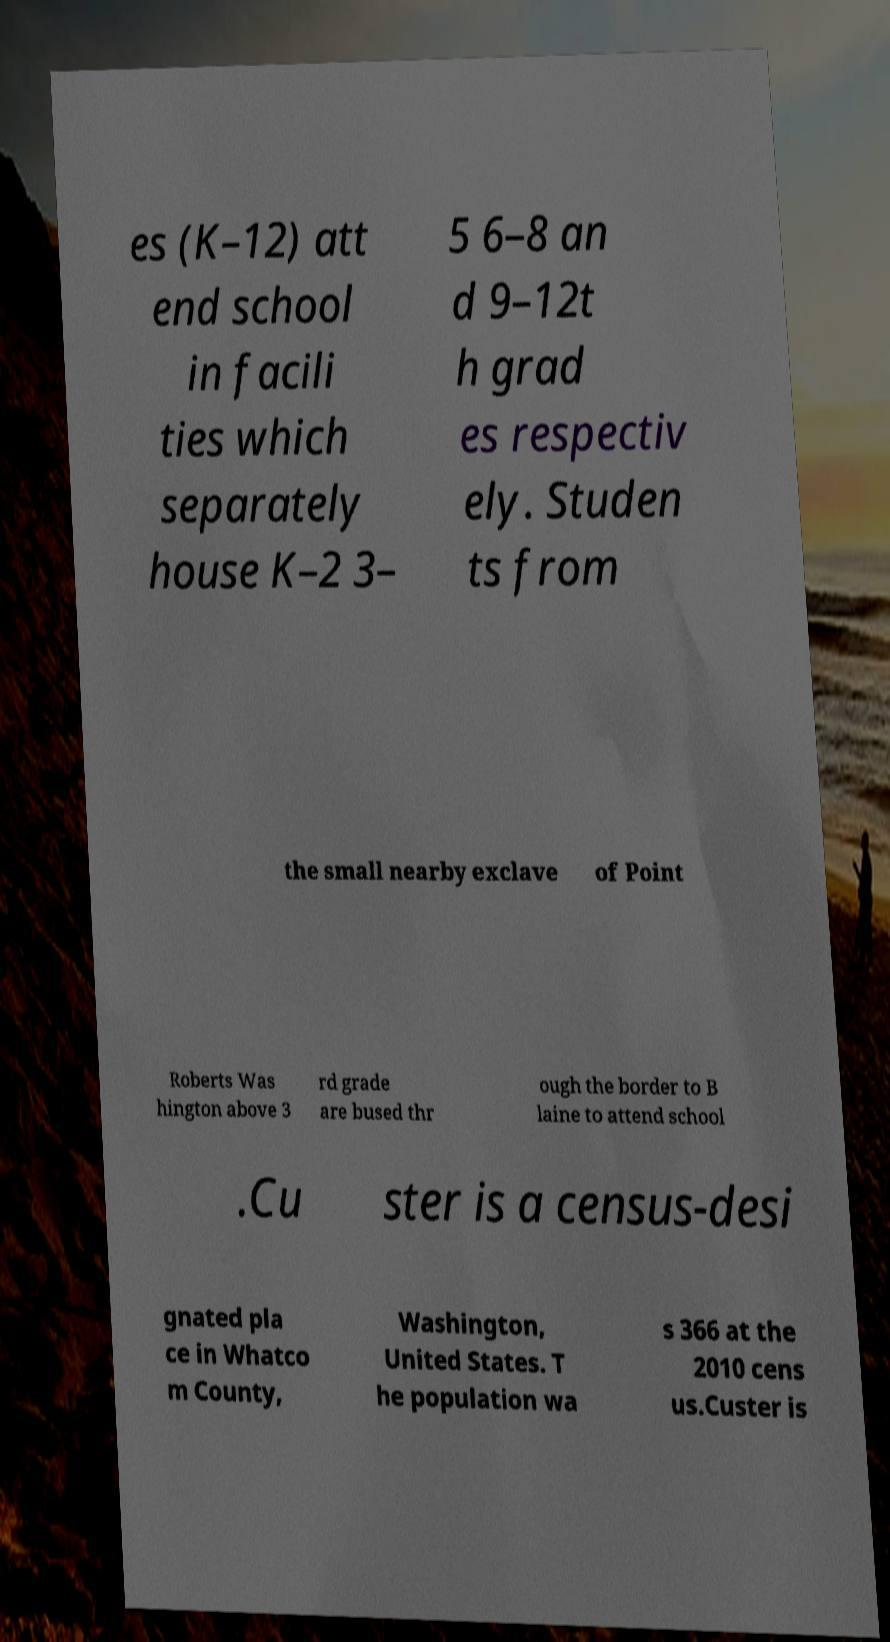Could you extract and type out the text from this image? es (K–12) att end school in facili ties which separately house K–2 3– 5 6–8 an d 9–12t h grad es respectiv ely. Studen ts from the small nearby exclave of Point Roberts Was hington above 3 rd grade are bused thr ough the border to B laine to attend school .Cu ster is a census-desi gnated pla ce in Whatco m County, Washington, United States. T he population wa s 366 at the 2010 cens us.Custer is 